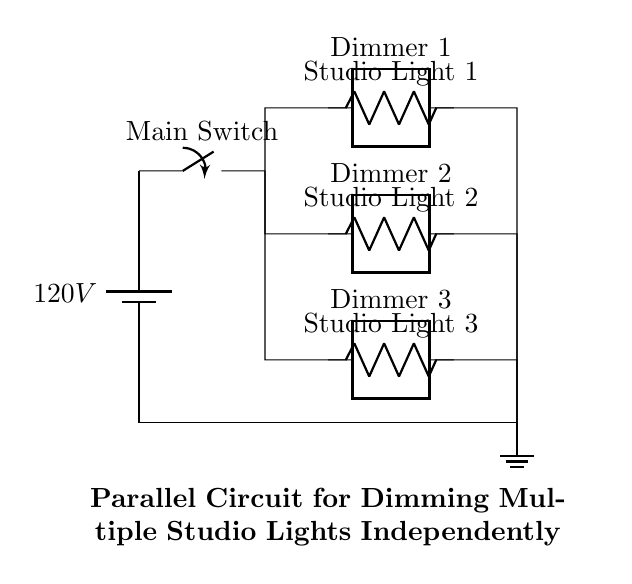What is the voltage of this circuit? The voltage is 120 volts, which is provided by the battery in the circuit.
Answer: 120 volts What type of circuit is shown? The circuit is a parallel circuit, as indicated by multiple branches connected to the same voltage source.
Answer: Parallel circuit How many dimmer switches are present? There are three dimmer switches, one for each studio light, as depicted in the circuit diagram.
Answer: Three Which component controls the overall power? The main switch controls the overall power by connecting or disconnecting the voltage supply.
Answer: Main switch What is the function of the resistors in this circuit? The resistors function as studio lights, where each one represents a light that can be dimmed independently.
Answer: Studio lights Can the studio lights be dimmed independently? Yes, each light is connected with its own dimmer, allowing independent control.
Answer: Yes What is the total number of branches in the circuit? There are four branches: one for the main power and three for the studio lights, each with their dimmers.
Answer: Four 